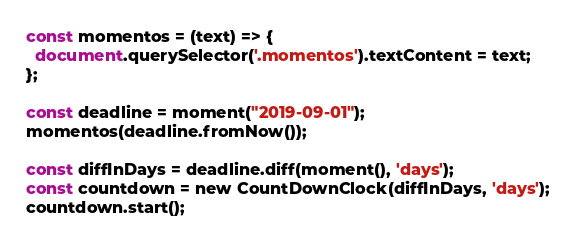<code> <loc_0><loc_0><loc_500><loc_500><_JavaScript_>const momentos = (text) => {
  document.querySelector('.momentos').textContent = text;
};

const deadline = moment("2019-09-01");
momentos(deadline.fromNow());

const diffInDays = deadline.diff(moment(), 'days');
const countdown = new CountDownClock(diffInDays, 'days');
countdown.start();
</code> 